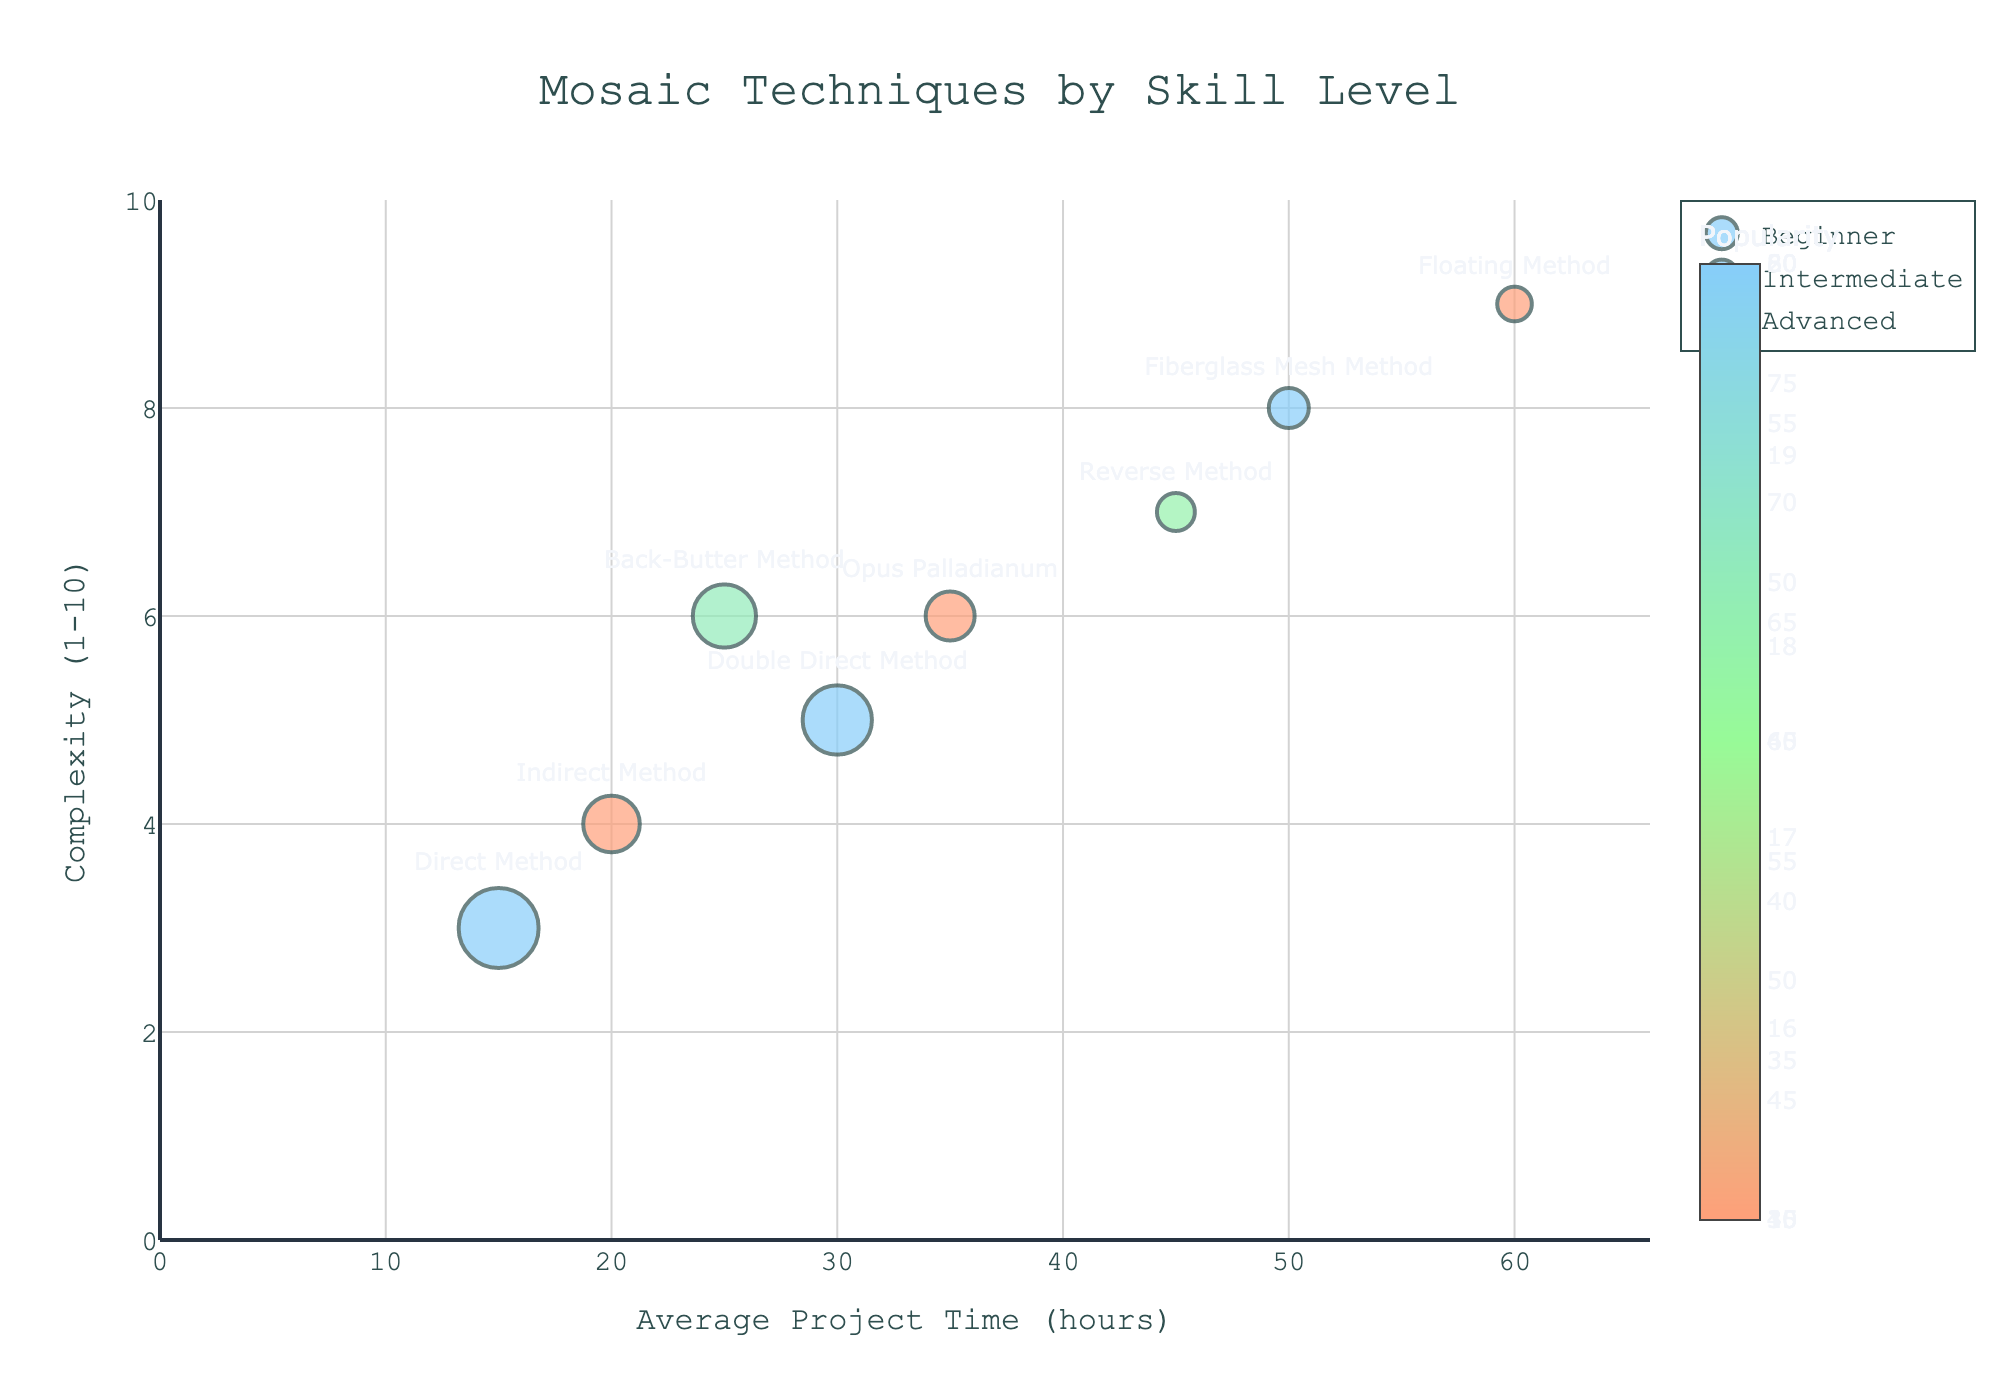How many mosaic techniques are depicted in the figure? The figure shows the labels for each mosaic technique. By counting all unique technique labels, we can determine the total number.
Answer: 8 What is the most popular technique for beginners? In the figure, popularity is indicated by the size of the bubbles. The largest bubble for beginners indicates the most popular technique.
Answer: Direct Method Which technique takes the longest average project time among advanced skill levels? The x-axis represents average project time. Among advanced techniques, find the bubble farthest to the right.
Answer: Floating Method Which intermediate technique has the highest complexity? The y-axis represents complexity. Among intermediate techniques, find the bubble highest on the y-axis.
Answer: Opus Palladianum Compare Indirect Method and Double Direct Method. Which is more popular and which takes longer to complete? Identify bubbles for both techniques. Use bubble size for popularity and x-axis position for average project time.
Answer: Direct Method is more popular; Double Direct Method takes longer What is the average complexity of techniques used by advanced skill levels? Sum the complexities of all advanced techniques and divide by the number of advanced techniques. (8 + 7 + 9) / 3 = 24 / 3.
Answer: 8 Which technique is used at all skill levels? Check if any technique name appears in bubbles labeled for beginner, intermediate, and advanced skill levels.
Answer: None How does complexity change with project time for intermediate techniques? Observe the general trend of intermediate bubbles from left to right across the x-axis to see if they rise along the y-axis.
Answer: Increases Is there any beginner technique more complex than the Back-Butter Method? Compare the y-axis value of beginner techniques to the y-axis value of Back-Butter Method (Complexity = 6).
Answer: No 